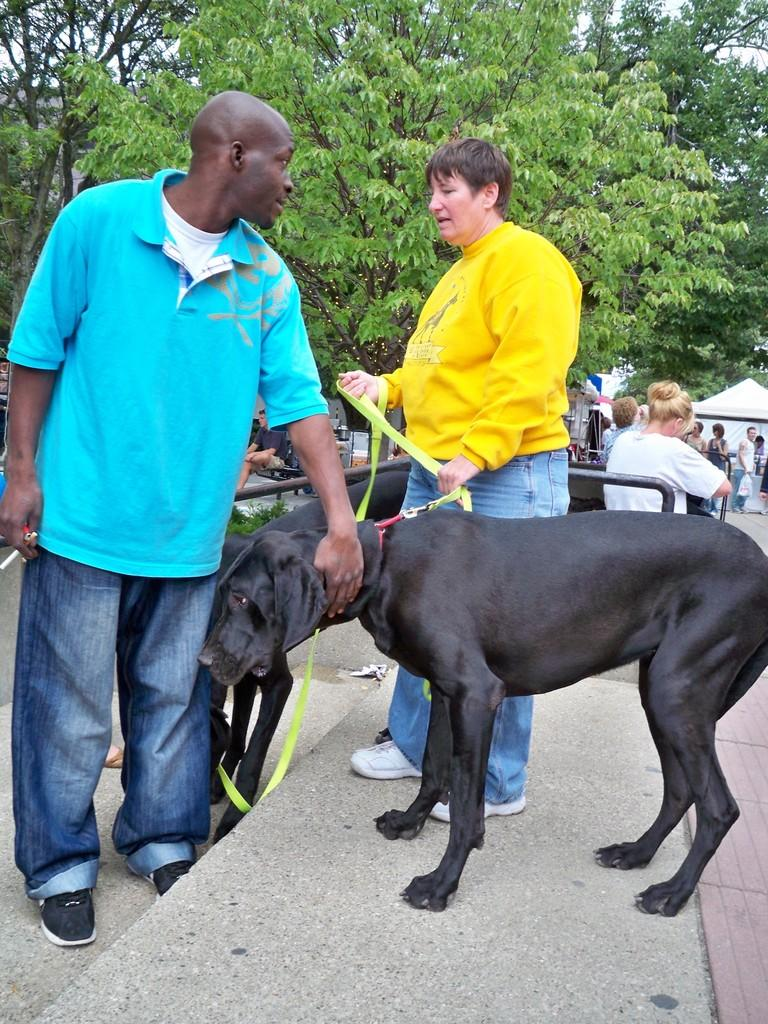What are the people in the image doing? The people in the image are standing on the road. What can be seen in the background of the image? There are trees visible at the back of the image. What other living creature is present on the road in the image? There is a dog standing on the road in the image. How many cats can be seen expressing their desire for a bike in the image? There are no cats present in the image, and therefore no such expression of desire can be observed. 